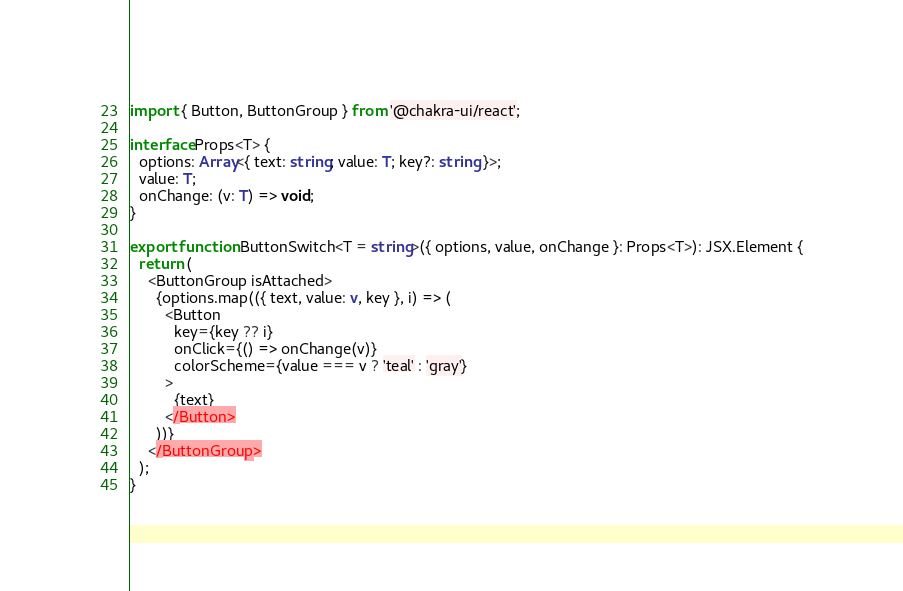Convert code to text. <code><loc_0><loc_0><loc_500><loc_500><_TypeScript_>import { Button, ButtonGroup } from '@chakra-ui/react';

interface Props<T> {
  options: Array<{ text: string; value: T; key?: string }>;
  value: T;
  onChange: (v: T) => void;
}

export function ButtonSwitch<T = string>({ options, value, onChange }: Props<T>): JSX.Element {
  return (
    <ButtonGroup isAttached>
      {options.map(({ text, value: v, key }, i) => (
        <Button
          key={key ?? i}
          onClick={() => onChange(v)}
          colorScheme={value === v ? 'teal' : 'gray'}
        >
          {text}
        </Button>
      ))}
    </ButtonGroup>
  );
}
</code> 